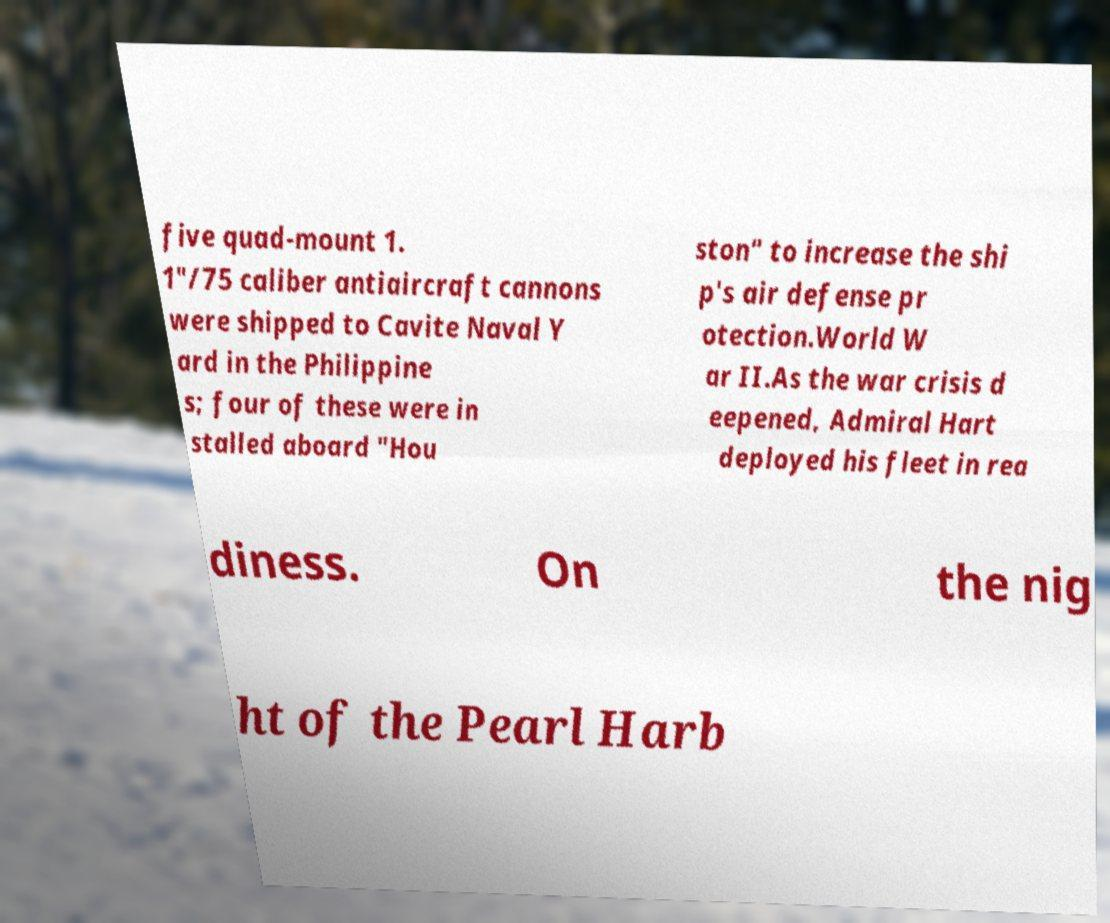What messages or text are displayed in this image? I need them in a readable, typed format. five quad-mount 1. 1"/75 caliber antiaircraft cannons were shipped to Cavite Naval Y ard in the Philippine s; four of these were in stalled aboard "Hou ston" to increase the shi p's air defense pr otection.World W ar II.As the war crisis d eepened, Admiral Hart deployed his fleet in rea diness. On the nig ht of the Pearl Harb 